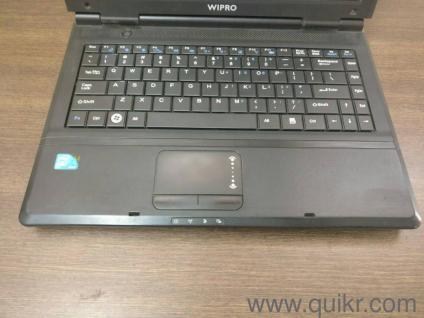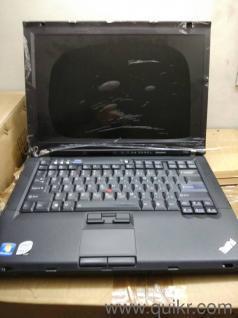The first image is the image on the left, the second image is the image on the right. Examine the images to the left and right. Is the description "Some laptops are stacked in multiple rows at least four to a stack." accurate? Answer yes or no. No. The first image is the image on the left, the second image is the image on the right. Analyze the images presented: Is the assertion "At least one image shows stacks of devices." valid? Answer yes or no. No. 